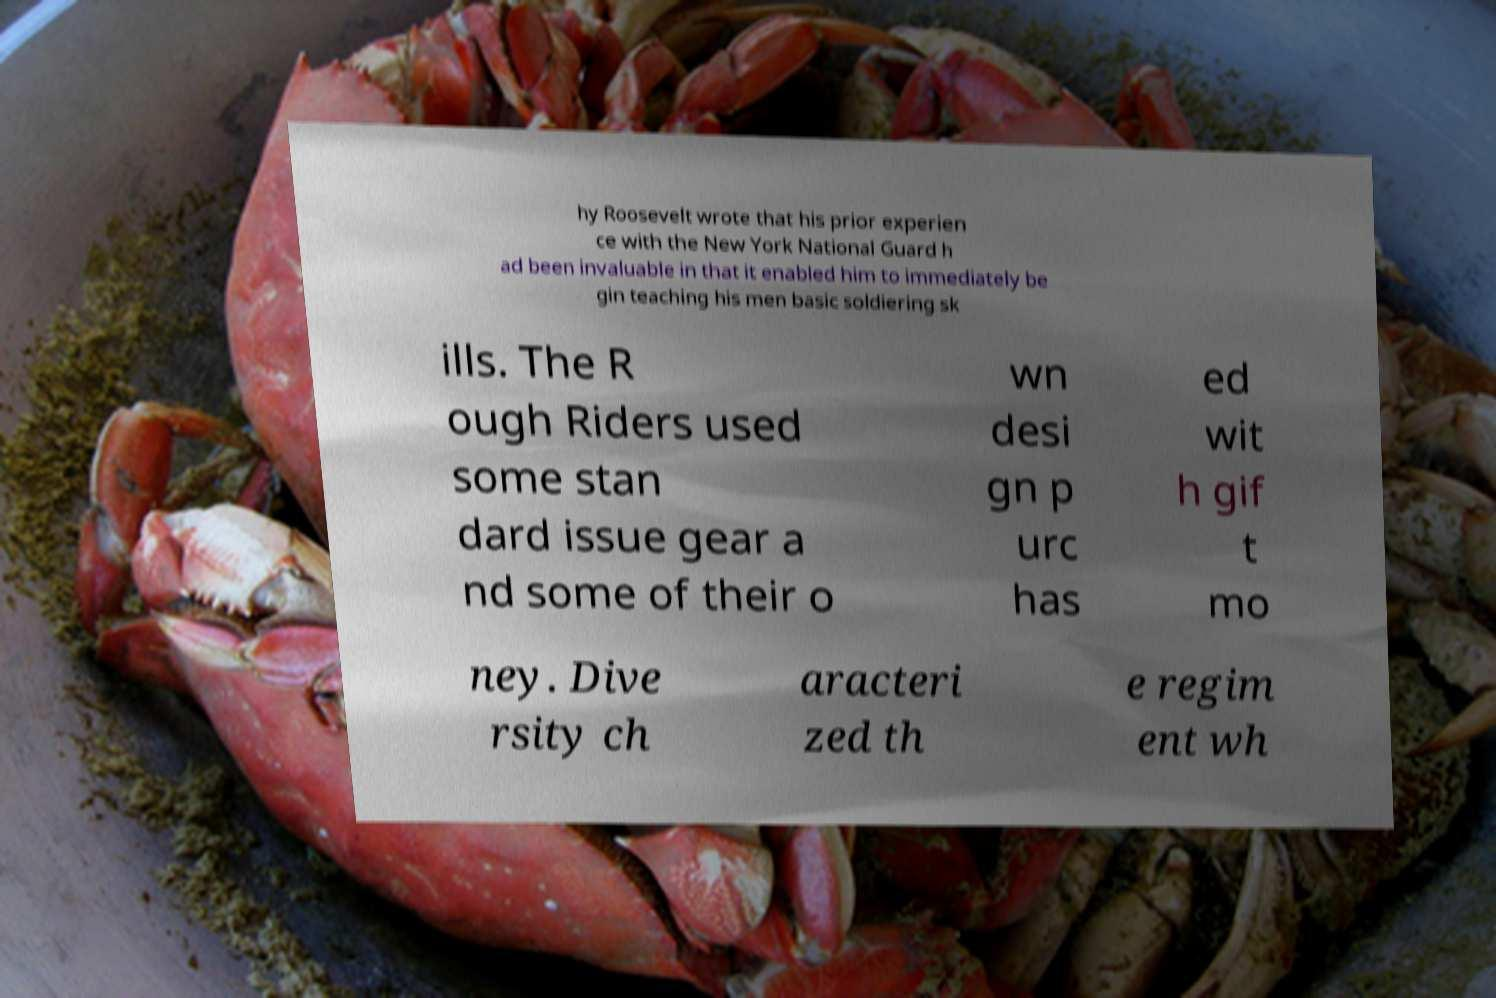Please identify and transcribe the text found in this image. hy Roosevelt wrote that his prior experien ce with the New York National Guard h ad been invaluable in that it enabled him to immediately be gin teaching his men basic soldiering sk ills. The R ough Riders used some stan dard issue gear a nd some of their o wn desi gn p urc has ed wit h gif t mo ney. Dive rsity ch aracteri zed th e regim ent wh 